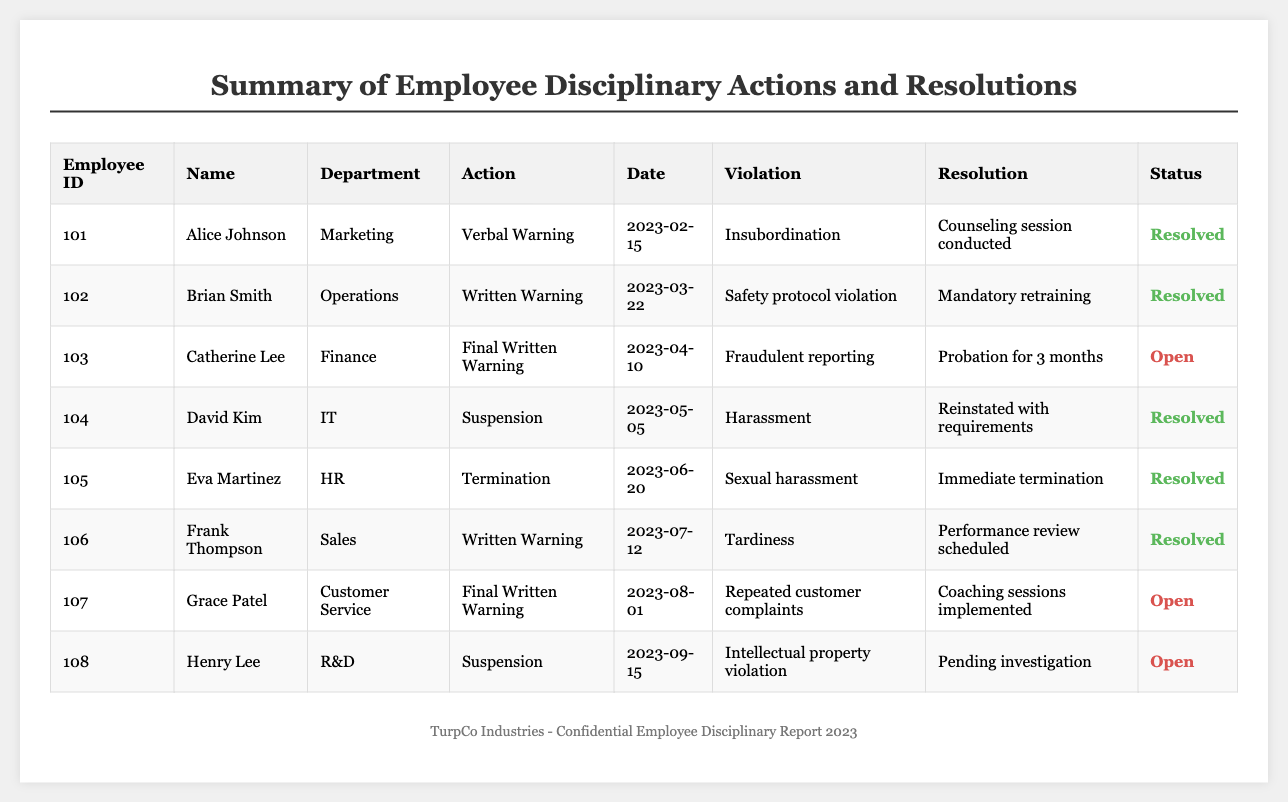What is the total number of resolved disciplinary actions? The table lists the status of disciplinary actions as either "Resolved" or "Open". Counting the rows with "Resolved" indicates there are 5 resolved actions (Alice Johnson, Brian Smith, David Kim, Eva Martinez, Frank Thompson).
Answer: 5 Which employee received a "Final Written Warning"? Looking through the disciplinary actions listed in the table, the employees who received a "Final Written Warning" are Catherine Lee and Grace Patel, as indicated in their respective rows.
Answer: Catherine Lee, Grace Patel What was the violation associated with Eva Martinez's disciplinary action? By examining the row for Eva Martinez, it shows that the violation for her termination was "Sexual harassment".
Answer: Sexual harassment How many disciplinary actions are currently open? The table provides a status for each disciplinary action. There are 3 actions marked as "Open" (Catherine Lee, Grace Patel, Henry Lee).
Answer: 3 Was there a case of sexual harassment that resulted in termination? Yes, Eva Martinez's disciplinary action for "Sexual harassment" resulted in "Immediate termination," confirming the occurrence.
Answer: Yes How many different types of disciplinary actions were issued in total? By reviewing the table, the types of disciplinary actions are "Verbal Warning," "Written Warning," "Final Written Warning," "Suspension," and "Termination." Counting these distinct types gives a total of 5 different actions.
Answer: 5 What was the resolution for the disciplinary action against Henry Lee? For Henry Lee, the table states that his case is marked as "Pending investigation," which is listed in the resolution column for his disciplinary action.
Answer: Pending investigation Which department had the employee with the most recent disciplinary action? The most recent disciplinary action is for Henry Lee from the "R&D" department, which occurred on "2023-09-15".
Answer: R&D Calculate the ratio of resolved to open disciplinary actions. There are 5 resolved and 3 open actions. The ratio is then calculated as 5:3, which can also be expressed numerically as 1.67 when simplified.
Answer: 5:3 (or 1.67) For which violation was a mandatory retraining required? The table indicates that Brian Smith required "Mandatory retraining" due to "Safety protocol violation," as stated in his disciplinary action row.
Answer: Safety protocol violation 